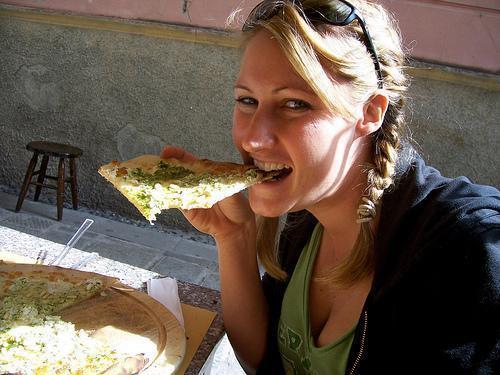How many people are there?
Give a very brief answer. 1. 